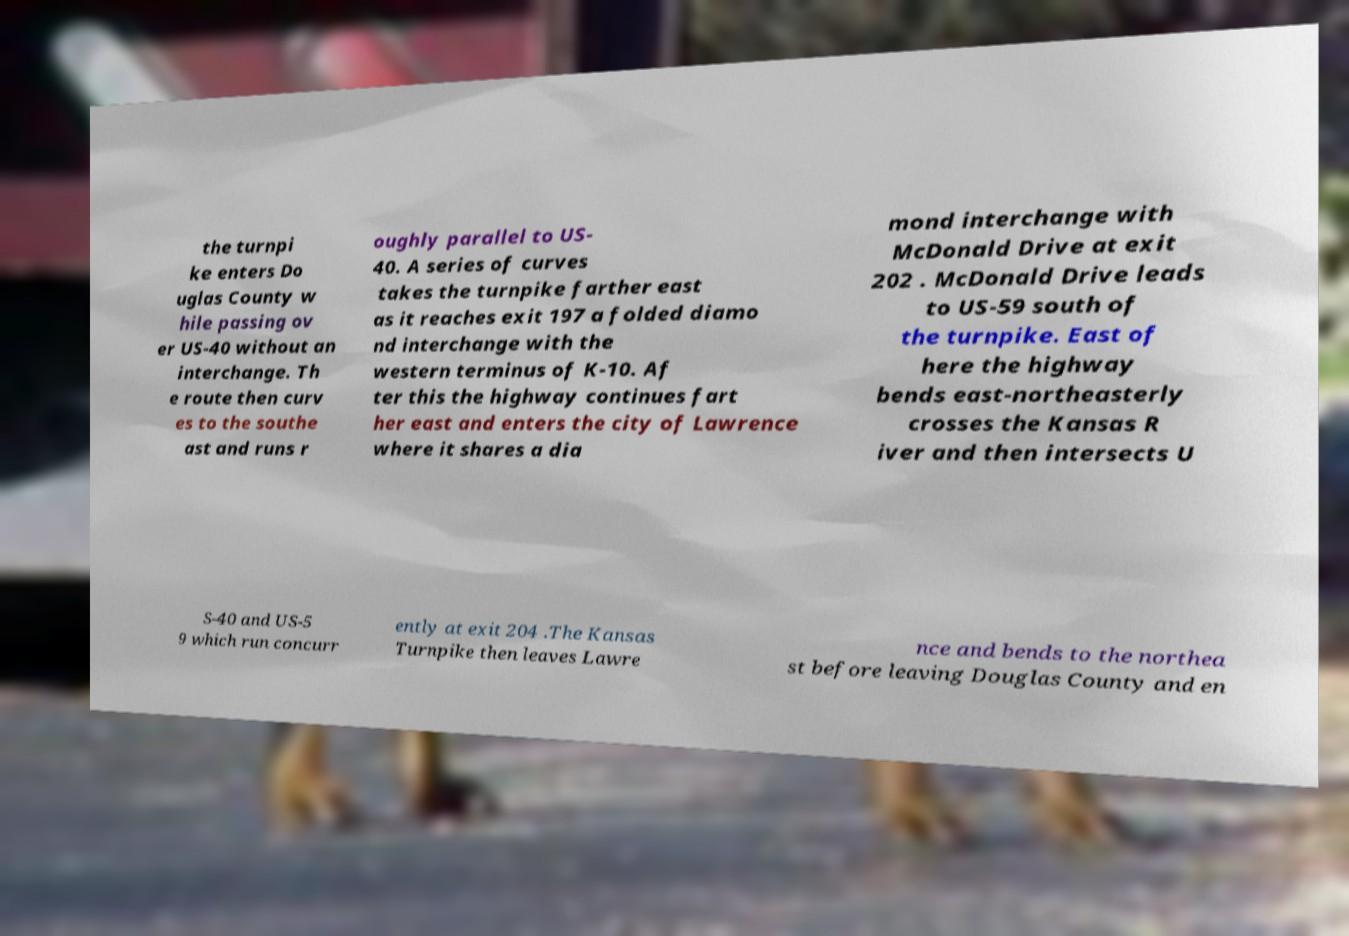Could you assist in decoding the text presented in this image and type it out clearly? the turnpi ke enters Do uglas County w hile passing ov er US-40 without an interchange. Th e route then curv es to the southe ast and runs r oughly parallel to US- 40. A series of curves takes the turnpike farther east as it reaches exit 197 a folded diamo nd interchange with the western terminus of K-10. Af ter this the highway continues fart her east and enters the city of Lawrence where it shares a dia mond interchange with McDonald Drive at exit 202 . McDonald Drive leads to US-59 south of the turnpike. East of here the highway bends east-northeasterly crosses the Kansas R iver and then intersects U S-40 and US-5 9 which run concurr ently at exit 204 .The Kansas Turnpike then leaves Lawre nce and bends to the northea st before leaving Douglas County and en 